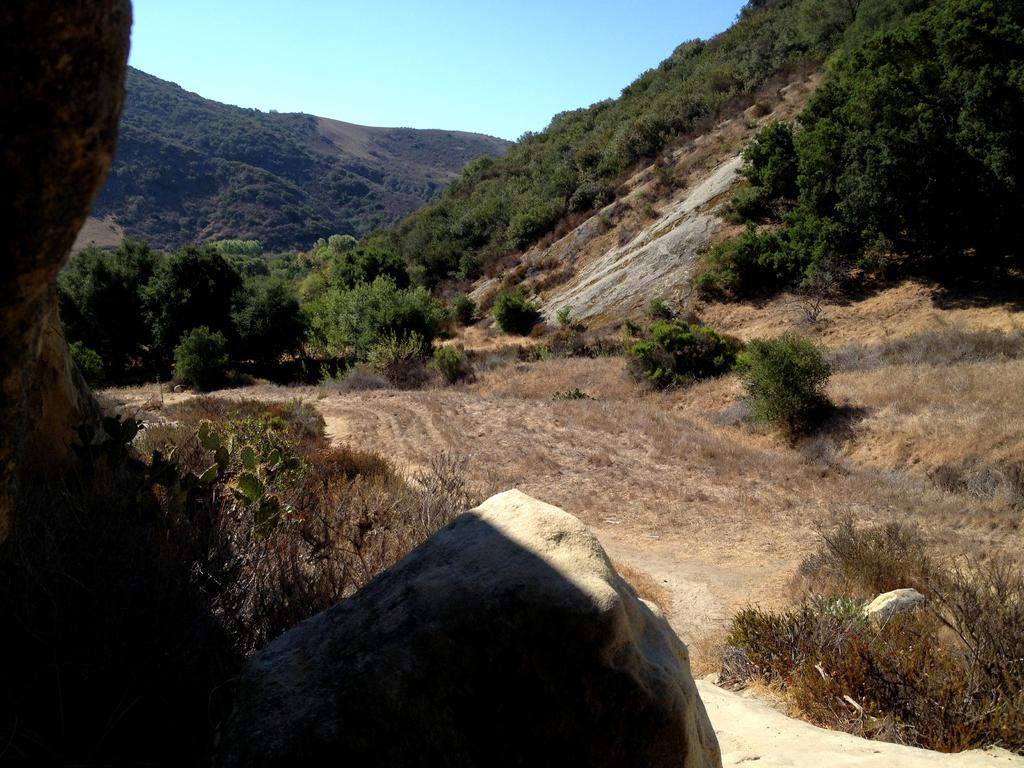What type of terrain is visible in the image? The ground is visible in the image, and there is grass, plants, trees, rocks, and hills present. What can be seen in the sky in the image? The sky is visible in the image. What type of ear can be seen in the image? There is no ear present in the image; it features a natural landscape with terrain elements such as grass, plants, trees, rocks, and hills. 